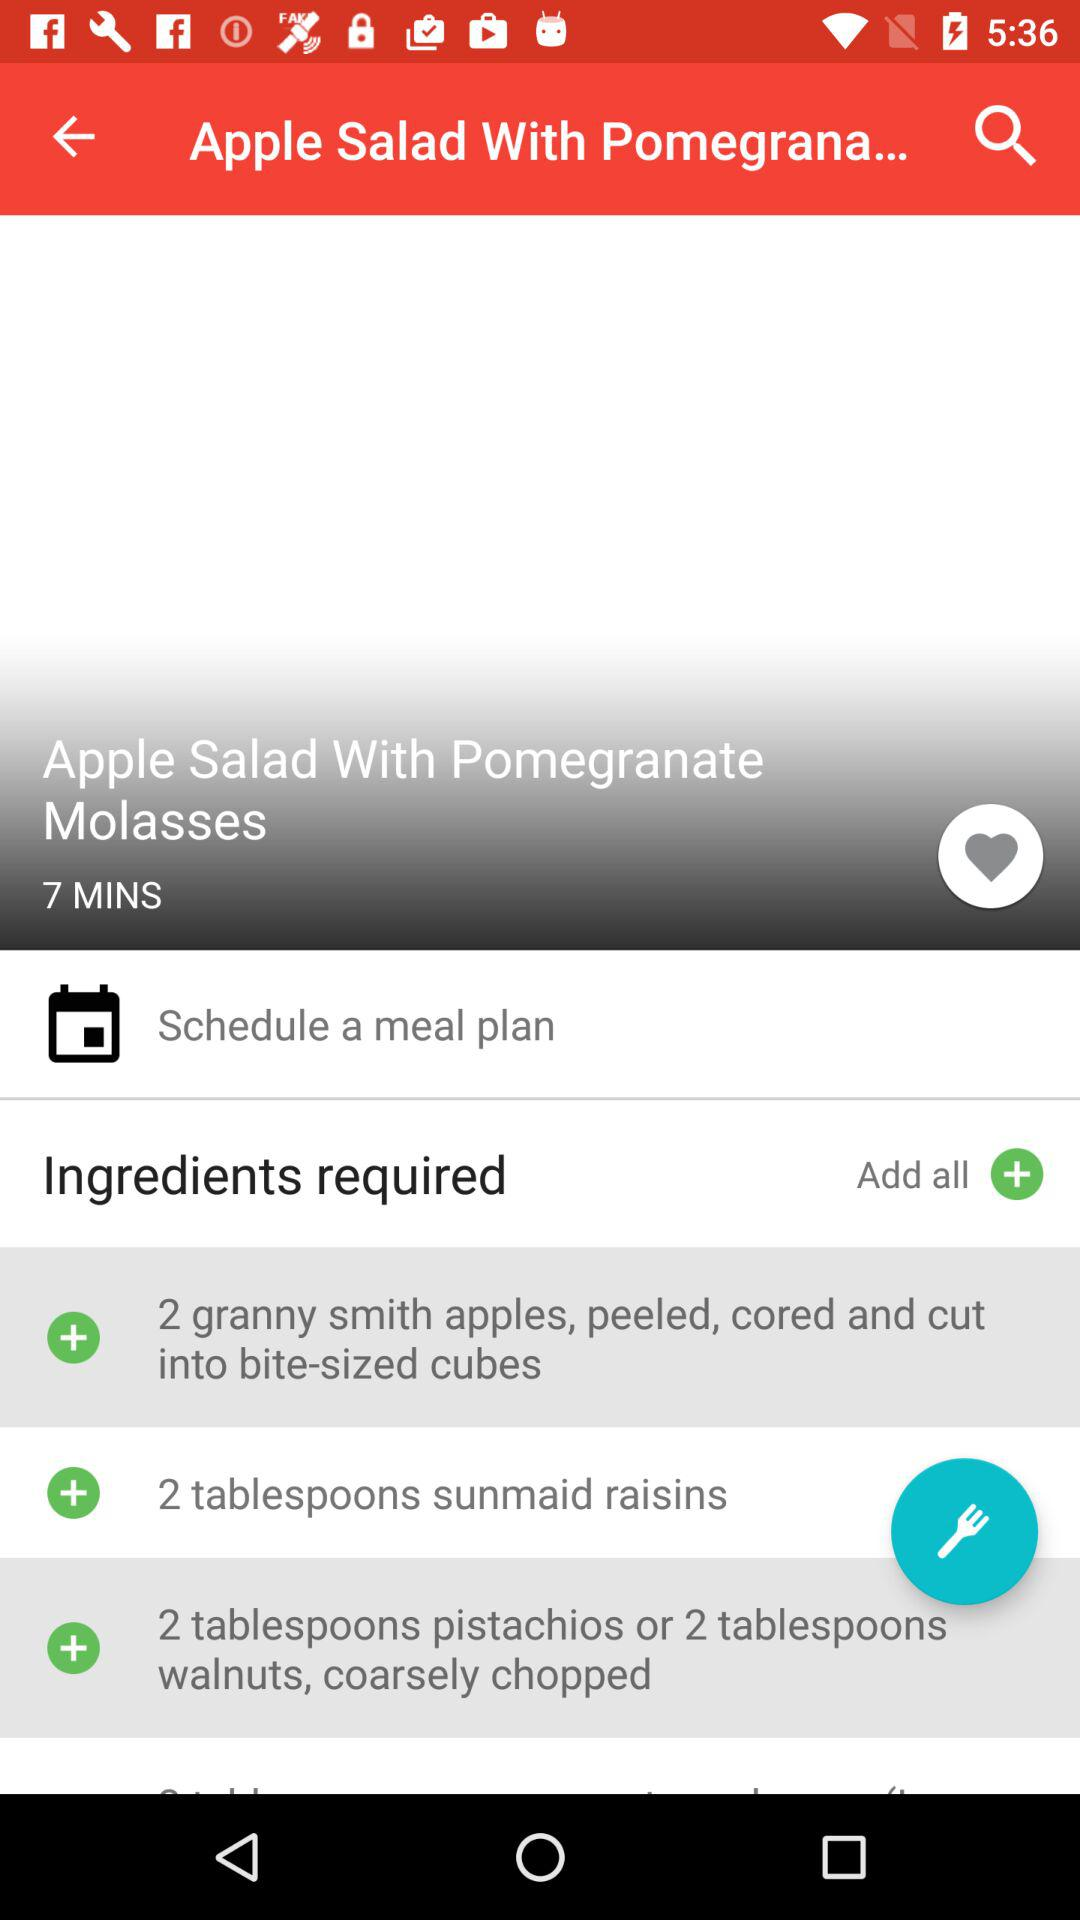How many ingredients are required to make this recipe?
Answer the question using a single word or phrase. 4 